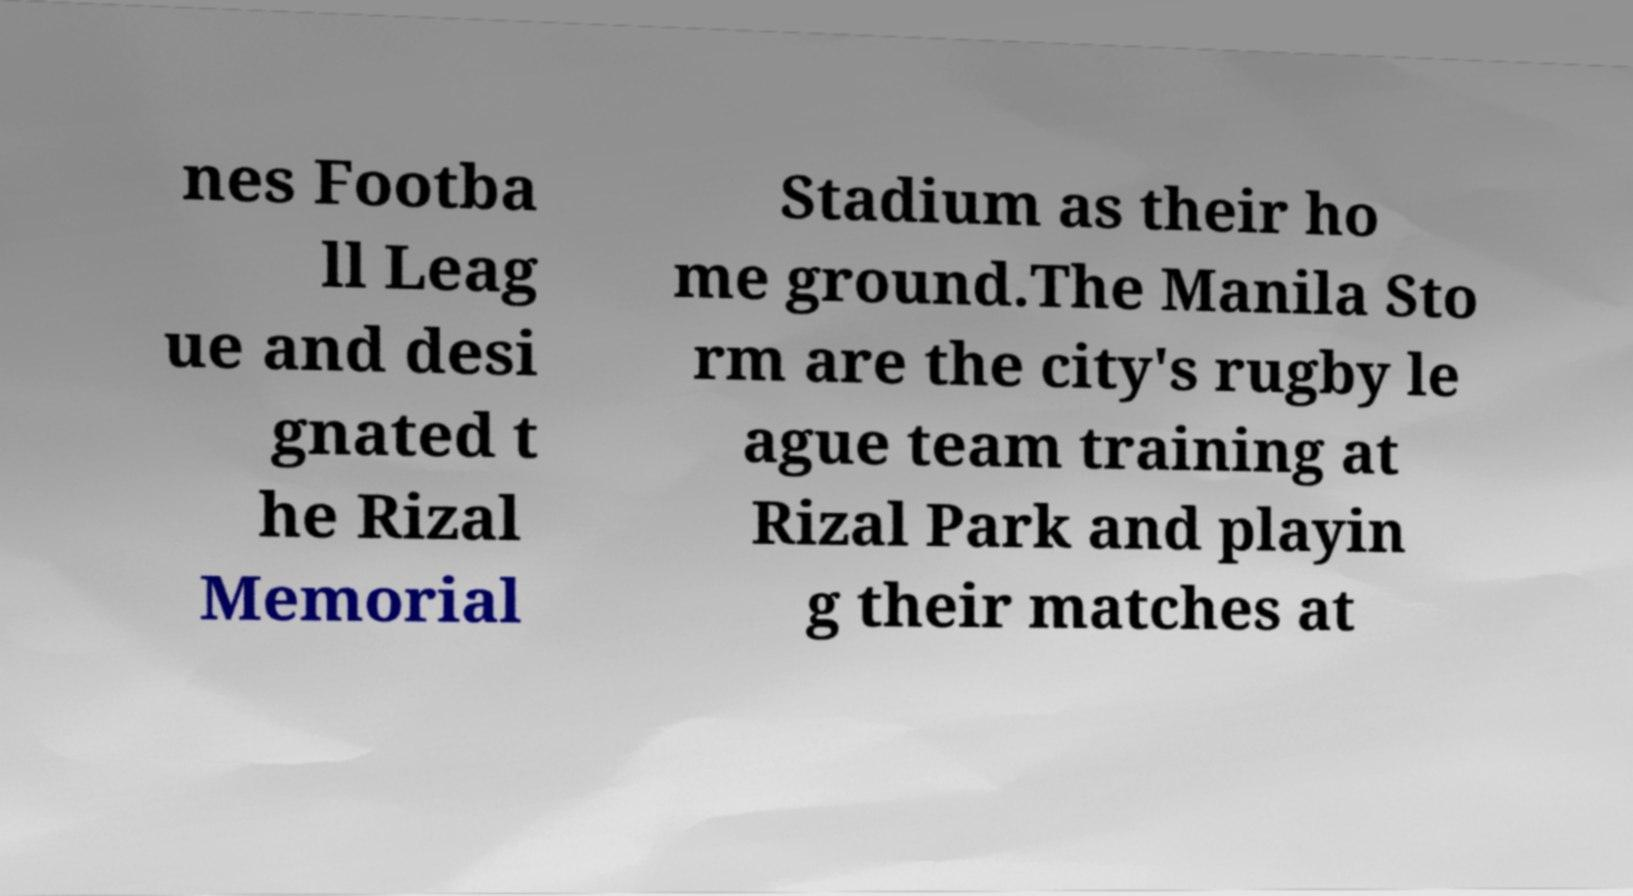Could you assist in decoding the text presented in this image and type it out clearly? nes Footba ll Leag ue and desi gnated t he Rizal Memorial Stadium as their ho me ground.The Manila Sto rm are the city's rugby le ague team training at Rizal Park and playin g their matches at 